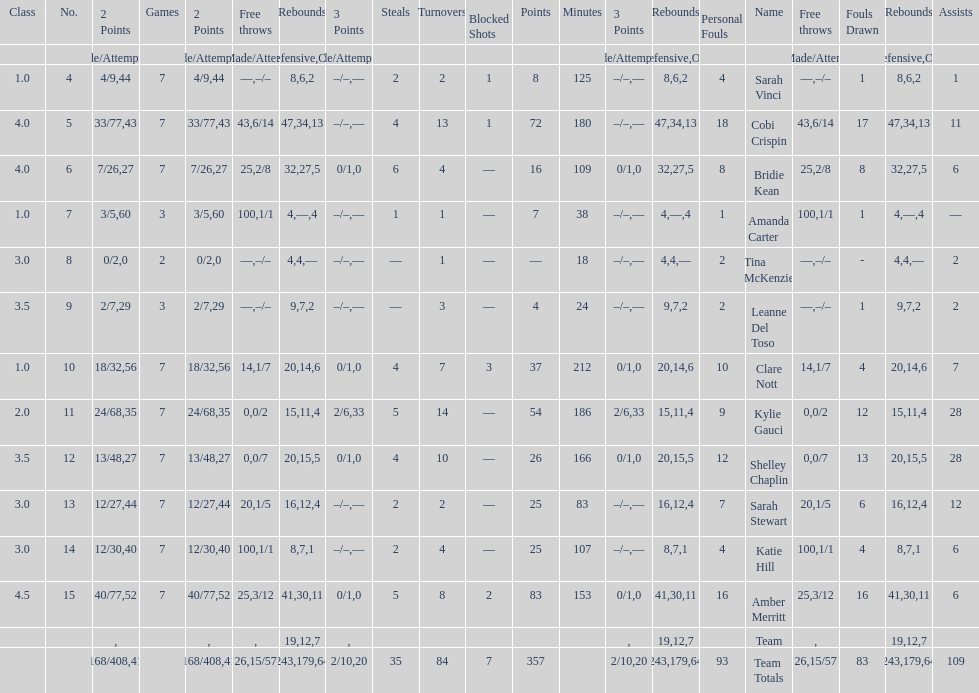What is the difference between the highest scoring player's points and the lowest scoring player's points? 83. Could you help me parse every detail presented in this table? {'header': ['Class', 'No.', '2 Points', 'Games', '2 Points', 'Free throws', 'Rebounds', '3 Points', 'Steals', 'Turnovers', 'Blocked Shots', 'Points', 'Minutes', '3 Points', 'Rebounds', 'Personal Fouls', 'Name', 'Free throws', 'Fouls Drawn', 'Rebounds', 'Assists'], 'rows': [['', '', 'Made/Attempts', '', '%', '%', 'Total', 'Made/Attempts', '', '', '', '', '', '%', 'Defensive', '', '', 'Made/Attempts', '', 'Offensive', ''], ['1.0', '4', '4/9', '7', '44', '—', '8', '–/–', '2', '2', '1', '8', '125', '—', '6', '4', 'Sarah Vinci', '–/–', '1', '2', '1'], ['4.0', '5', '33/77', '7', '43', '43', '47', '–/–', '4', '13', '1', '72', '180', '—', '34', '18', 'Cobi Crispin', '6/14', '17', '13', '11'], ['4.0', '6', '7/26', '7', '27', '25', '32', '0/1', '6', '4', '—', '16', '109', '0', '27', '8', 'Bridie Kean', '2/8', '8', '5', '6'], ['1.0', '7', '3/5', '3', '60', '100', '4', '–/–', '1', '1', '—', '7', '38', '—', '—', '1', 'Amanda Carter', '1/1', '1', '4', '—'], ['3.0', '8', '0/2', '2', '0', '—', '4', '–/–', '—', '1', '—', '—', '18', '—', '4', '2', 'Tina McKenzie', '–/–', '-', '—', '2'], ['3.5', '9', '2/7', '3', '29', '—', '9', '–/–', '—', '3', '—', '4', '24', '—', '7', '2', 'Leanne Del Toso', '–/–', '1', '2', '2'], ['1.0', '10', '18/32', '7', '56', '14', '20', '0/1', '4', '7', '3', '37', '212', '0', '14', '10', 'Clare Nott', '1/7', '4', '6', '7'], ['2.0', '11', '24/68', '7', '35', '0', '15', '2/6', '5', '14', '—', '54', '186', '33', '11', '9', 'Kylie Gauci', '0/2', '12', '4', '28'], ['3.5', '12', '13/48', '7', '27', '0', '20', '0/1', '4', '10', '—', '26', '166', '0', '15', '12', 'Shelley Chaplin', '0/7', '13', '5', '28'], ['3.0', '13', '12/27', '7', '44', '20', '16', '–/–', '2', '2', '—', '25', '83', '—', '12', '7', 'Sarah Stewart', '1/5', '6', '4', '12'], ['3.0', '14', '12/30', '7', '40', '100', '8', '–/–', '2', '4', '—', '25', '107', '—', '7', '4', 'Katie Hill', '1/1', '4', '1', '6'], ['4.5', '15', '40/77', '7', '52', '25', '41', '0/1', '5', '8', '2', '83', '153', '0', '30', '16', 'Amber Merritt', '3/12', '16', '11', '6'], ['', '', '', '', '', '', '19', '', '', '', '', '', '', '', '12', '', 'Team', '', '', '7', ''], ['', '', '168/408', '', '41', '26', '243', '2/10', '35', '84', '7', '357', '', '20', '179', '93', 'Team Totals', '15/57', '83', '64', '109']]} 